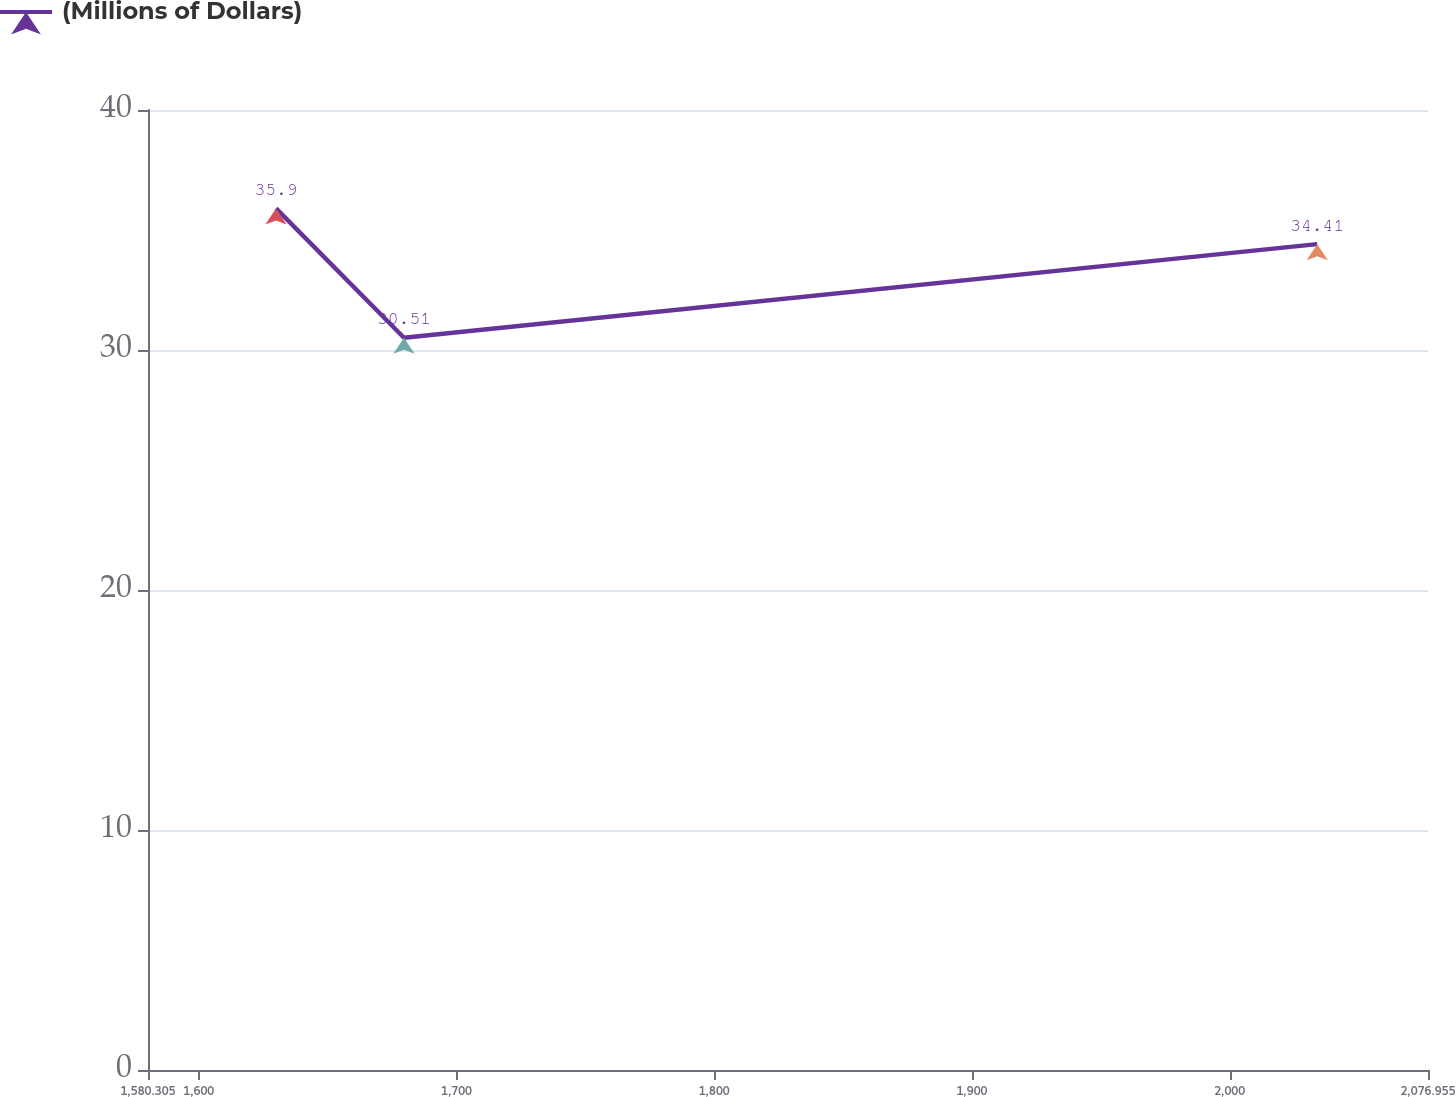<chart> <loc_0><loc_0><loc_500><loc_500><line_chart><ecel><fcel>(Millions of Dollars)<nl><fcel>1629.97<fcel>35.9<nl><fcel>1679.63<fcel>30.51<nl><fcel>2033.97<fcel>34.41<nl><fcel>2126.62<fcel>29.91<nl></chart> 